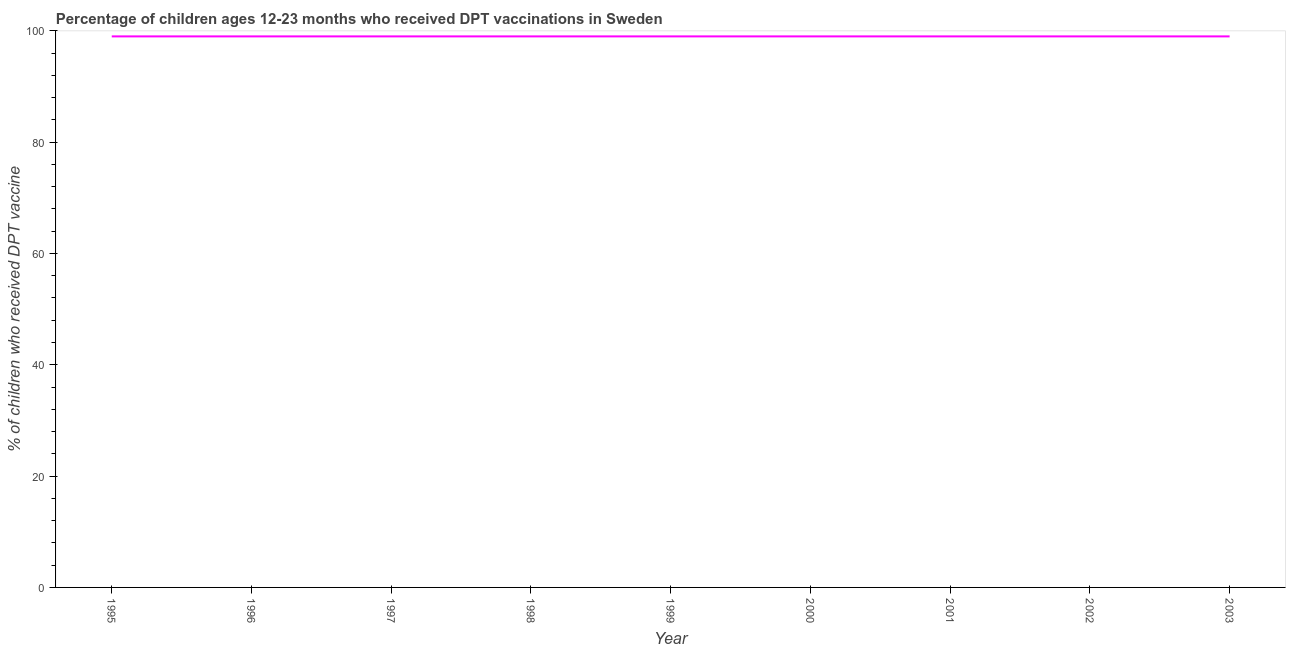What is the percentage of children who received dpt vaccine in 2001?
Make the answer very short. 99. Across all years, what is the maximum percentage of children who received dpt vaccine?
Your answer should be compact. 99. Across all years, what is the minimum percentage of children who received dpt vaccine?
Give a very brief answer. 99. In which year was the percentage of children who received dpt vaccine minimum?
Provide a short and direct response. 1995. What is the sum of the percentage of children who received dpt vaccine?
Provide a short and direct response. 891. What is the average percentage of children who received dpt vaccine per year?
Your answer should be compact. 99. What is the median percentage of children who received dpt vaccine?
Provide a succinct answer. 99. In how many years, is the percentage of children who received dpt vaccine greater than 68 %?
Provide a succinct answer. 9. Is the percentage of children who received dpt vaccine in 1996 less than that in 1999?
Offer a very short reply. No. Is the sum of the percentage of children who received dpt vaccine in 1995 and 2001 greater than the maximum percentage of children who received dpt vaccine across all years?
Offer a very short reply. Yes. What is the difference between the highest and the lowest percentage of children who received dpt vaccine?
Your answer should be very brief. 0. In how many years, is the percentage of children who received dpt vaccine greater than the average percentage of children who received dpt vaccine taken over all years?
Provide a short and direct response. 0. Does the percentage of children who received dpt vaccine monotonically increase over the years?
Provide a short and direct response. No. How many years are there in the graph?
Your response must be concise. 9. Does the graph contain grids?
Make the answer very short. No. What is the title of the graph?
Offer a terse response. Percentage of children ages 12-23 months who received DPT vaccinations in Sweden. What is the label or title of the Y-axis?
Give a very brief answer. % of children who received DPT vaccine. What is the % of children who received DPT vaccine of 1995?
Offer a very short reply. 99. What is the % of children who received DPT vaccine in 1996?
Keep it short and to the point. 99. What is the % of children who received DPT vaccine of 2002?
Ensure brevity in your answer.  99. What is the % of children who received DPT vaccine in 2003?
Give a very brief answer. 99. What is the difference between the % of children who received DPT vaccine in 1995 and 1996?
Make the answer very short. 0. What is the difference between the % of children who received DPT vaccine in 1995 and 1997?
Give a very brief answer. 0. What is the difference between the % of children who received DPT vaccine in 1995 and 1998?
Make the answer very short. 0. What is the difference between the % of children who received DPT vaccine in 1995 and 1999?
Ensure brevity in your answer.  0. What is the difference between the % of children who received DPT vaccine in 1996 and 1997?
Provide a short and direct response. 0. What is the difference between the % of children who received DPT vaccine in 1996 and 1998?
Offer a terse response. 0. What is the difference between the % of children who received DPT vaccine in 1996 and 1999?
Keep it short and to the point. 0. What is the difference between the % of children who received DPT vaccine in 1996 and 2003?
Your answer should be very brief. 0. What is the difference between the % of children who received DPT vaccine in 1997 and 1998?
Give a very brief answer. 0. What is the difference between the % of children who received DPT vaccine in 1997 and 1999?
Your answer should be compact. 0. What is the difference between the % of children who received DPT vaccine in 1997 and 2003?
Give a very brief answer. 0. What is the difference between the % of children who received DPT vaccine in 1998 and 2001?
Provide a succinct answer. 0. What is the difference between the % of children who received DPT vaccine in 1998 and 2002?
Provide a short and direct response. 0. What is the difference between the % of children who received DPT vaccine in 1999 and 2001?
Your answer should be compact. 0. What is the difference between the % of children who received DPT vaccine in 1999 and 2002?
Offer a terse response. 0. What is the difference between the % of children who received DPT vaccine in 2000 and 2001?
Your response must be concise. 0. What is the difference between the % of children who received DPT vaccine in 2000 and 2002?
Keep it short and to the point. 0. What is the difference between the % of children who received DPT vaccine in 2001 and 2002?
Your answer should be compact. 0. What is the difference between the % of children who received DPT vaccine in 2002 and 2003?
Ensure brevity in your answer.  0. What is the ratio of the % of children who received DPT vaccine in 1995 to that in 1997?
Give a very brief answer. 1. What is the ratio of the % of children who received DPT vaccine in 1995 to that in 1998?
Your response must be concise. 1. What is the ratio of the % of children who received DPT vaccine in 1995 to that in 1999?
Provide a succinct answer. 1. What is the ratio of the % of children who received DPT vaccine in 1995 to that in 2000?
Your answer should be compact. 1. What is the ratio of the % of children who received DPT vaccine in 1995 to that in 2001?
Make the answer very short. 1. What is the ratio of the % of children who received DPT vaccine in 1995 to that in 2003?
Provide a short and direct response. 1. What is the ratio of the % of children who received DPT vaccine in 1996 to that in 1997?
Keep it short and to the point. 1. What is the ratio of the % of children who received DPT vaccine in 1996 to that in 1998?
Offer a very short reply. 1. What is the ratio of the % of children who received DPT vaccine in 1996 to that in 1999?
Give a very brief answer. 1. What is the ratio of the % of children who received DPT vaccine in 1996 to that in 2000?
Make the answer very short. 1. What is the ratio of the % of children who received DPT vaccine in 1997 to that in 1998?
Provide a short and direct response. 1. What is the ratio of the % of children who received DPT vaccine in 1997 to that in 1999?
Your answer should be very brief. 1. What is the ratio of the % of children who received DPT vaccine in 1997 to that in 2000?
Make the answer very short. 1. What is the ratio of the % of children who received DPT vaccine in 1997 to that in 2001?
Ensure brevity in your answer.  1. What is the ratio of the % of children who received DPT vaccine in 1997 to that in 2003?
Offer a very short reply. 1. What is the ratio of the % of children who received DPT vaccine in 1998 to that in 1999?
Your answer should be compact. 1. What is the ratio of the % of children who received DPT vaccine in 1998 to that in 2002?
Make the answer very short. 1. What is the ratio of the % of children who received DPT vaccine in 1998 to that in 2003?
Provide a short and direct response. 1. What is the ratio of the % of children who received DPT vaccine in 1999 to that in 2000?
Make the answer very short. 1. What is the ratio of the % of children who received DPT vaccine in 1999 to that in 2001?
Ensure brevity in your answer.  1. What is the ratio of the % of children who received DPT vaccine in 1999 to that in 2002?
Keep it short and to the point. 1. What is the ratio of the % of children who received DPT vaccine in 1999 to that in 2003?
Offer a very short reply. 1. What is the ratio of the % of children who received DPT vaccine in 2000 to that in 2001?
Keep it short and to the point. 1. What is the ratio of the % of children who received DPT vaccine in 2000 to that in 2003?
Offer a very short reply. 1. What is the ratio of the % of children who received DPT vaccine in 2001 to that in 2002?
Offer a terse response. 1. What is the ratio of the % of children who received DPT vaccine in 2002 to that in 2003?
Make the answer very short. 1. 